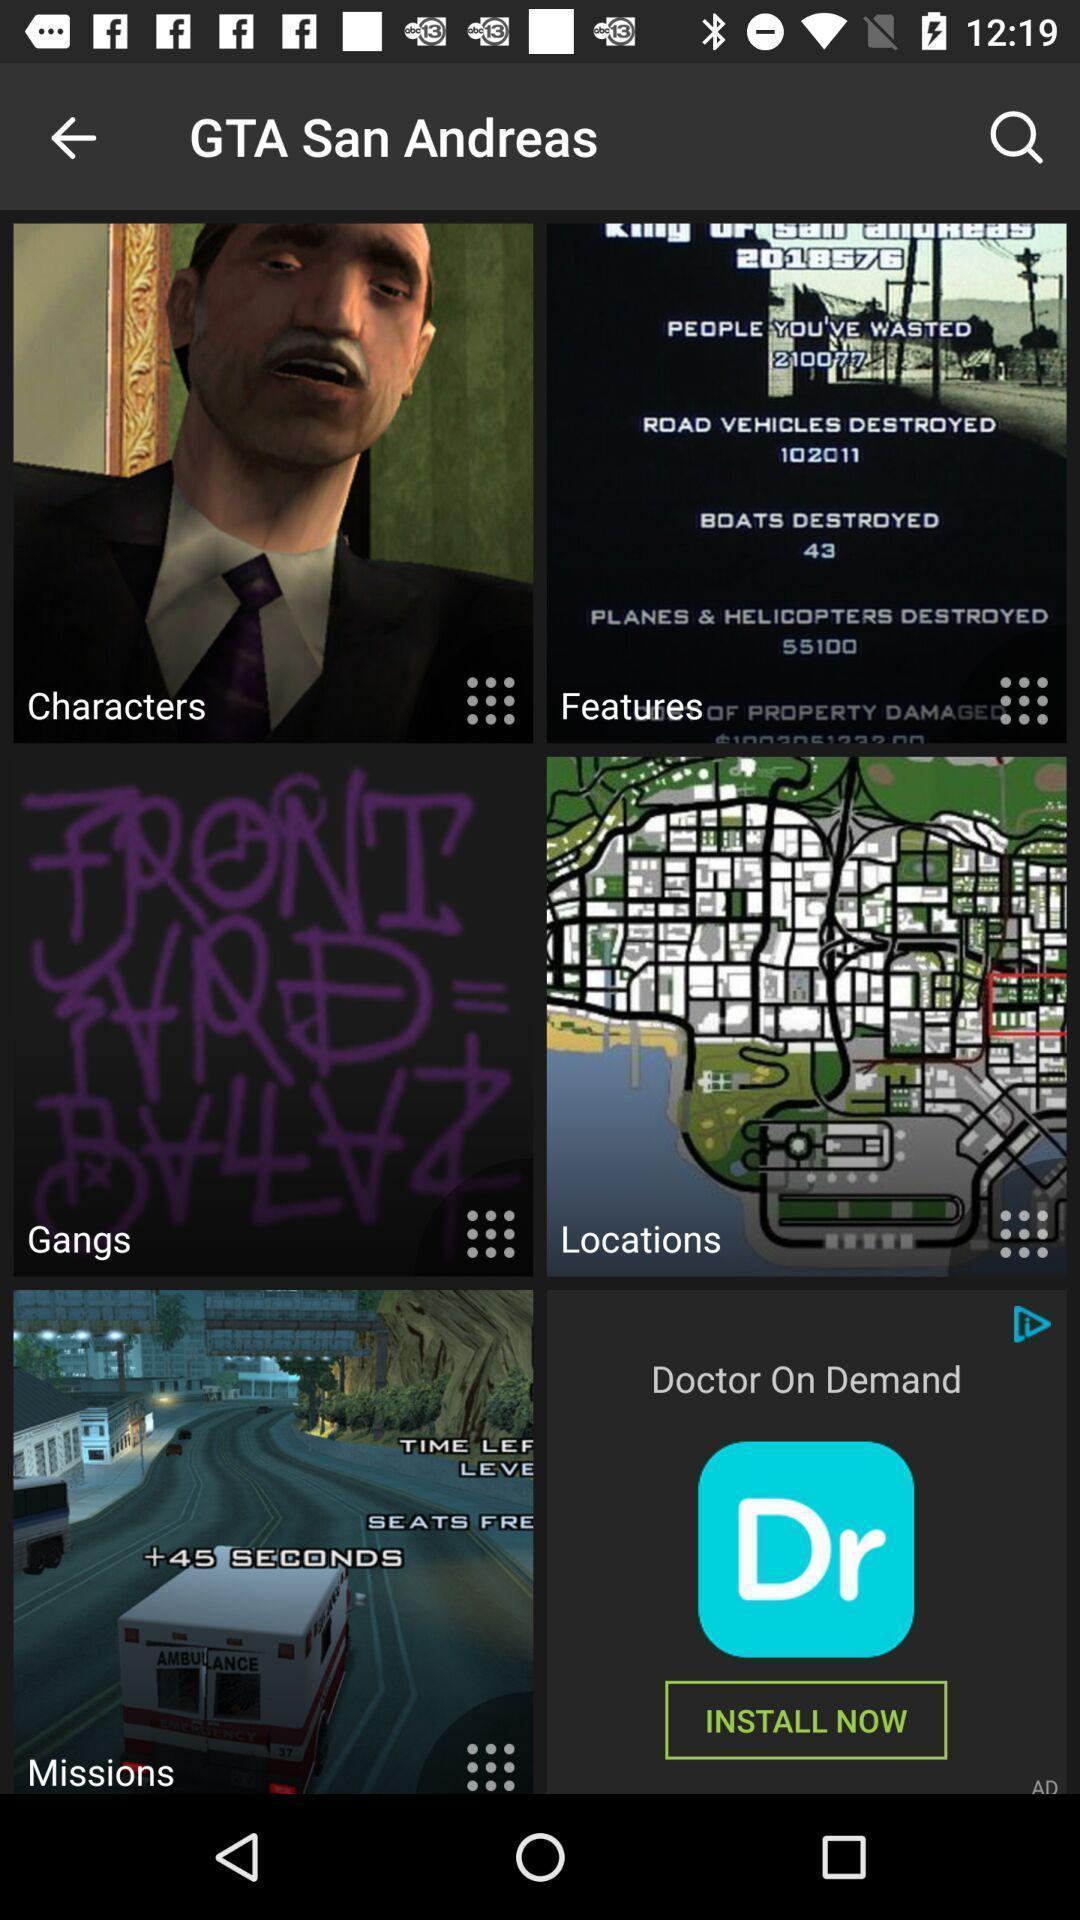Summarize the main components in this picture. Screen about list of game details. 